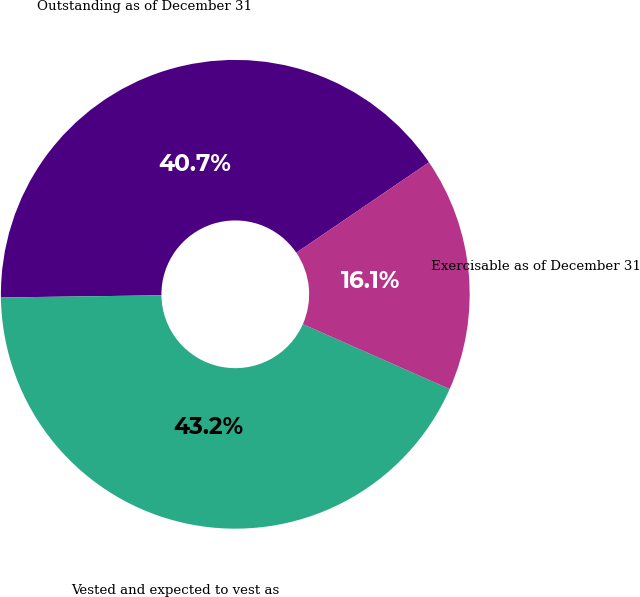Convert chart to OTSL. <chart><loc_0><loc_0><loc_500><loc_500><pie_chart><fcel>Outstanding as of December 31<fcel>Vested and expected to vest as<fcel>Exercisable as of December 31<nl><fcel>40.7%<fcel>43.16%<fcel>16.14%<nl></chart> 